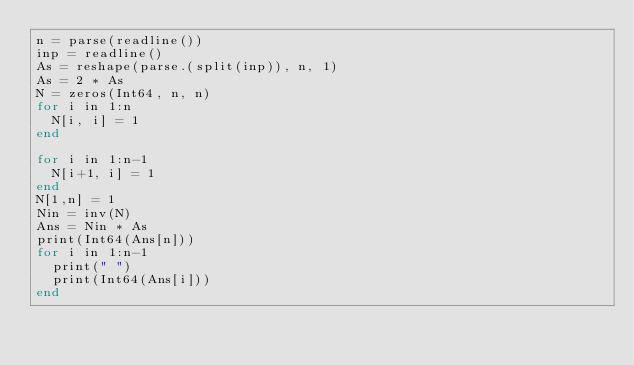<code> <loc_0><loc_0><loc_500><loc_500><_Julia_>n = parse(readline())
inp = readline()
As = reshape(parse.(split(inp)), n, 1)
As = 2 * As                                                                  
N = zeros(Int64, n, n)
for i in 1:n
	N[i, i] = 1
end

for i in 1:n-1
	N[i+1, i] = 1
end
N[1,n] = 1
Nin = inv(N)
Ans = Nin * As
print(Int64(Ans[n]))
for i in 1:n-1
	print(" ")
	print(Int64(Ans[i]))
end</code> 